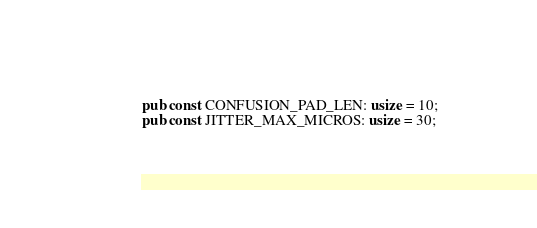<code> <loc_0><loc_0><loc_500><loc_500><_Rust_>pub const CONFUSION_PAD_LEN: usize = 10;
pub const JITTER_MAX_MICROS: usize = 30;</code> 